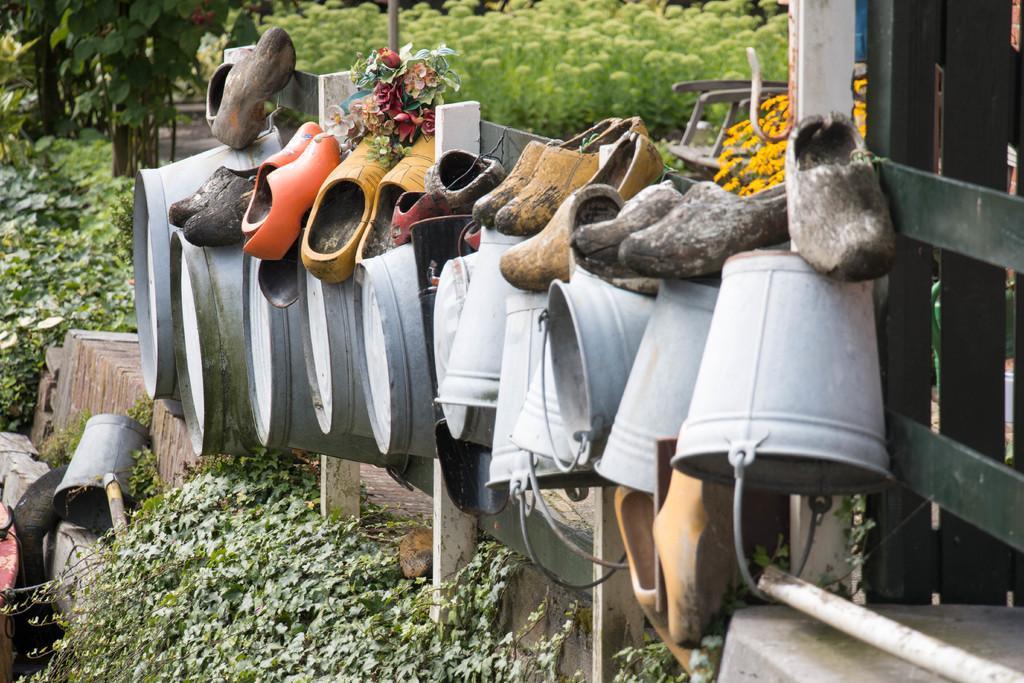In one or two sentences, can you explain what this image depicts? In the center of the image we can see buckets and shoes. In the background we can see trees, plants and chair. At the bottom of the image we can see plants. 